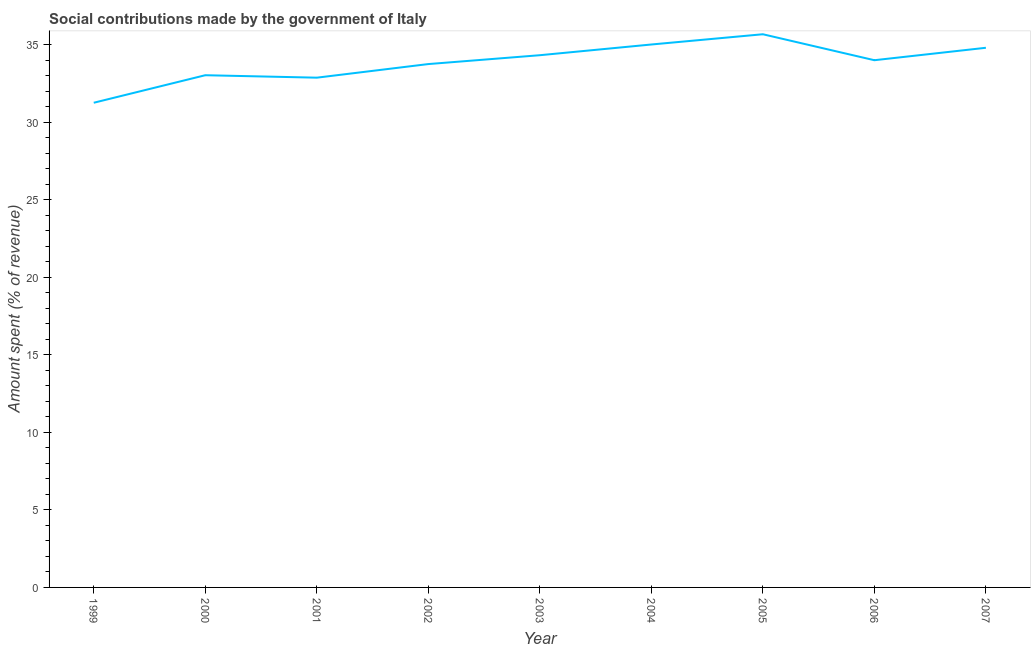What is the amount spent in making social contributions in 2002?
Your answer should be very brief. 33.74. Across all years, what is the maximum amount spent in making social contributions?
Your answer should be compact. 35.67. Across all years, what is the minimum amount spent in making social contributions?
Ensure brevity in your answer.  31.25. In which year was the amount spent in making social contributions maximum?
Provide a short and direct response. 2005. What is the sum of the amount spent in making social contributions?
Your answer should be compact. 304.65. What is the difference between the amount spent in making social contributions in 2001 and 2004?
Keep it short and to the point. -2.14. What is the average amount spent in making social contributions per year?
Offer a very short reply. 33.85. What is the median amount spent in making social contributions?
Keep it short and to the point. 33.99. What is the ratio of the amount spent in making social contributions in 2001 to that in 2004?
Give a very brief answer. 0.94. Is the amount spent in making social contributions in 2005 less than that in 2006?
Offer a very short reply. No. What is the difference between the highest and the second highest amount spent in making social contributions?
Offer a terse response. 0.66. What is the difference between the highest and the lowest amount spent in making social contributions?
Provide a succinct answer. 4.42. What is the difference between two consecutive major ticks on the Y-axis?
Your answer should be very brief. 5. Are the values on the major ticks of Y-axis written in scientific E-notation?
Offer a very short reply. No. What is the title of the graph?
Offer a very short reply. Social contributions made by the government of Italy. What is the label or title of the X-axis?
Offer a very short reply. Year. What is the label or title of the Y-axis?
Provide a succinct answer. Amount spent (% of revenue). What is the Amount spent (% of revenue) of 1999?
Keep it short and to the point. 31.25. What is the Amount spent (% of revenue) in 2000?
Keep it short and to the point. 33.02. What is the Amount spent (% of revenue) of 2001?
Give a very brief answer. 32.87. What is the Amount spent (% of revenue) of 2002?
Your answer should be compact. 33.74. What is the Amount spent (% of revenue) in 2003?
Provide a short and direct response. 34.31. What is the Amount spent (% of revenue) in 2004?
Provide a succinct answer. 35. What is the Amount spent (% of revenue) in 2005?
Your answer should be compact. 35.67. What is the Amount spent (% of revenue) in 2006?
Keep it short and to the point. 33.99. What is the Amount spent (% of revenue) of 2007?
Your answer should be compact. 34.79. What is the difference between the Amount spent (% of revenue) in 1999 and 2000?
Ensure brevity in your answer.  -1.77. What is the difference between the Amount spent (% of revenue) in 1999 and 2001?
Keep it short and to the point. -1.62. What is the difference between the Amount spent (% of revenue) in 1999 and 2002?
Your answer should be very brief. -2.49. What is the difference between the Amount spent (% of revenue) in 1999 and 2003?
Offer a terse response. -3.06. What is the difference between the Amount spent (% of revenue) in 1999 and 2004?
Provide a succinct answer. -3.76. What is the difference between the Amount spent (% of revenue) in 1999 and 2005?
Provide a succinct answer. -4.42. What is the difference between the Amount spent (% of revenue) in 1999 and 2006?
Provide a succinct answer. -2.74. What is the difference between the Amount spent (% of revenue) in 1999 and 2007?
Your answer should be very brief. -3.54. What is the difference between the Amount spent (% of revenue) in 2000 and 2001?
Your answer should be compact. 0.16. What is the difference between the Amount spent (% of revenue) in 2000 and 2002?
Offer a terse response. -0.72. What is the difference between the Amount spent (% of revenue) in 2000 and 2003?
Make the answer very short. -1.29. What is the difference between the Amount spent (% of revenue) in 2000 and 2004?
Ensure brevity in your answer.  -1.98. What is the difference between the Amount spent (% of revenue) in 2000 and 2005?
Your answer should be very brief. -2.64. What is the difference between the Amount spent (% of revenue) in 2000 and 2006?
Make the answer very short. -0.97. What is the difference between the Amount spent (% of revenue) in 2000 and 2007?
Offer a very short reply. -1.77. What is the difference between the Amount spent (% of revenue) in 2001 and 2002?
Offer a terse response. -0.88. What is the difference between the Amount spent (% of revenue) in 2001 and 2003?
Your response must be concise. -1.45. What is the difference between the Amount spent (% of revenue) in 2001 and 2004?
Give a very brief answer. -2.14. What is the difference between the Amount spent (% of revenue) in 2001 and 2005?
Give a very brief answer. -2.8. What is the difference between the Amount spent (% of revenue) in 2001 and 2006?
Keep it short and to the point. -1.13. What is the difference between the Amount spent (% of revenue) in 2001 and 2007?
Your response must be concise. -1.93. What is the difference between the Amount spent (% of revenue) in 2002 and 2003?
Provide a succinct answer. -0.57. What is the difference between the Amount spent (% of revenue) in 2002 and 2004?
Offer a terse response. -1.26. What is the difference between the Amount spent (% of revenue) in 2002 and 2005?
Provide a succinct answer. -1.92. What is the difference between the Amount spent (% of revenue) in 2002 and 2006?
Offer a terse response. -0.25. What is the difference between the Amount spent (% of revenue) in 2002 and 2007?
Your response must be concise. -1.05. What is the difference between the Amount spent (% of revenue) in 2003 and 2004?
Ensure brevity in your answer.  -0.69. What is the difference between the Amount spent (% of revenue) in 2003 and 2005?
Give a very brief answer. -1.35. What is the difference between the Amount spent (% of revenue) in 2003 and 2006?
Offer a very short reply. 0.32. What is the difference between the Amount spent (% of revenue) in 2003 and 2007?
Make the answer very short. -0.48. What is the difference between the Amount spent (% of revenue) in 2004 and 2005?
Your answer should be compact. -0.66. What is the difference between the Amount spent (% of revenue) in 2004 and 2006?
Make the answer very short. 1.01. What is the difference between the Amount spent (% of revenue) in 2004 and 2007?
Provide a succinct answer. 0.21. What is the difference between the Amount spent (% of revenue) in 2005 and 2006?
Offer a very short reply. 1.67. What is the difference between the Amount spent (% of revenue) in 2005 and 2007?
Offer a terse response. 0.87. What is the difference between the Amount spent (% of revenue) in 2006 and 2007?
Offer a very short reply. -0.8. What is the ratio of the Amount spent (% of revenue) in 1999 to that in 2000?
Keep it short and to the point. 0.95. What is the ratio of the Amount spent (% of revenue) in 1999 to that in 2001?
Your response must be concise. 0.95. What is the ratio of the Amount spent (% of revenue) in 1999 to that in 2002?
Your answer should be compact. 0.93. What is the ratio of the Amount spent (% of revenue) in 1999 to that in 2003?
Offer a very short reply. 0.91. What is the ratio of the Amount spent (% of revenue) in 1999 to that in 2004?
Make the answer very short. 0.89. What is the ratio of the Amount spent (% of revenue) in 1999 to that in 2005?
Your answer should be very brief. 0.88. What is the ratio of the Amount spent (% of revenue) in 1999 to that in 2006?
Provide a succinct answer. 0.92. What is the ratio of the Amount spent (% of revenue) in 1999 to that in 2007?
Offer a very short reply. 0.9. What is the ratio of the Amount spent (% of revenue) in 2000 to that in 2001?
Your response must be concise. 1. What is the ratio of the Amount spent (% of revenue) in 2000 to that in 2004?
Offer a terse response. 0.94. What is the ratio of the Amount spent (% of revenue) in 2000 to that in 2005?
Offer a terse response. 0.93. What is the ratio of the Amount spent (% of revenue) in 2000 to that in 2006?
Keep it short and to the point. 0.97. What is the ratio of the Amount spent (% of revenue) in 2000 to that in 2007?
Your answer should be very brief. 0.95. What is the ratio of the Amount spent (% of revenue) in 2001 to that in 2003?
Your answer should be very brief. 0.96. What is the ratio of the Amount spent (% of revenue) in 2001 to that in 2004?
Provide a short and direct response. 0.94. What is the ratio of the Amount spent (% of revenue) in 2001 to that in 2005?
Make the answer very short. 0.92. What is the ratio of the Amount spent (% of revenue) in 2001 to that in 2006?
Give a very brief answer. 0.97. What is the ratio of the Amount spent (% of revenue) in 2001 to that in 2007?
Keep it short and to the point. 0.94. What is the ratio of the Amount spent (% of revenue) in 2002 to that in 2003?
Your response must be concise. 0.98. What is the ratio of the Amount spent (% of revenue) in 2002 to that in 2005?
Your answer should be compact. 0.95. What is the ratio of the Amount spent (% of revenue) in 2002 to that in 2006?
Your response must be concise. 0.99. What is the ratio of the Amount spent (% of revenue) in 2003 to that in 2005?
Make the answer very short. 0.96. What is the ratio of the Amount spent (% of revenue) in 2003 to that in 2006?
Keep it short and to the point. 1.01. What is the ratio of the Amount spent (% of revenue) in 2003 to that in 2007?
Keep it short and to the point. 0.99. What is the ratio of the Amount spent (% of revenue) in 2005 to that in 2006?
Your response must be concise. 1.05. What is the ratio of the Amount spent (% of revenue) in 2005 to that in 2007?
Offer a very short reply. 1.02. 